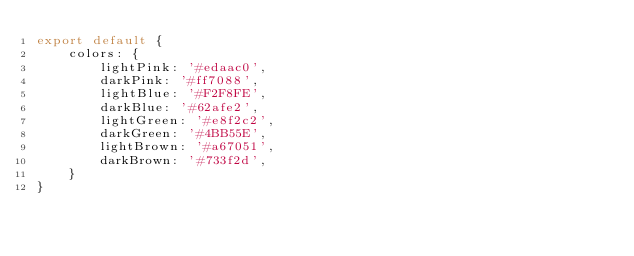<code> <loc_0><loc_0><loc_500><loc_500><_TypeScript_>export default {
    colors: {
        lightPink: '#edaac0',
        darkPink: '#ff7088',
        lightBlue: '#F2F8FE',
        darkBlue: '#62afe2',
        lightGreen: '#e8f2c2',
        darkGreen: '#4BB55E',
        lightBrown: '#a67051',
        darkBrown: '#733f2d',
    }
}</code> 